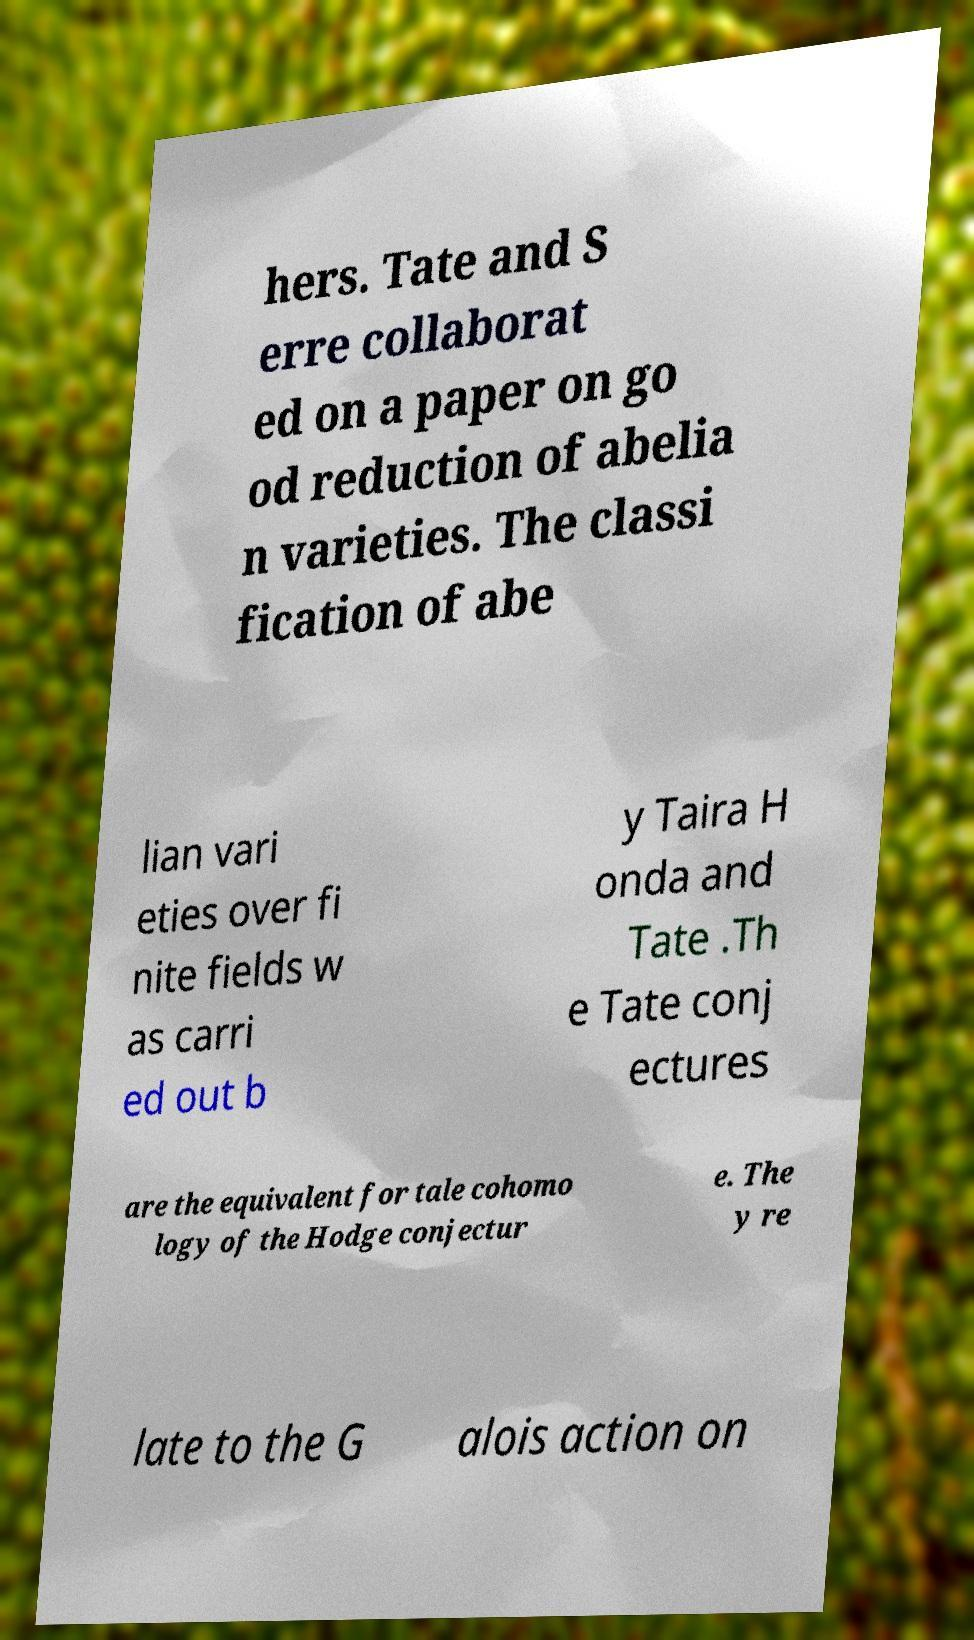What messages or text are displayed in this image? I need them in a readable, typed format. hers. Tate and S erre collaborat ed on a paper on go od reduction of abelia n varieties. The classi fication of abe lian vari eties over fi nite fields w as carri ed out b y Taira H onda and Tate .Th e Tate conj ectures are the equivalent for tale cohomo logy of the Hodge conjectur e. The y re late to the G alois action on 